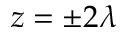Convert formula to latex. <formula><loc_0><loc_0><loc_500><loc_500>z = \pm 2 \lambda</formula> 